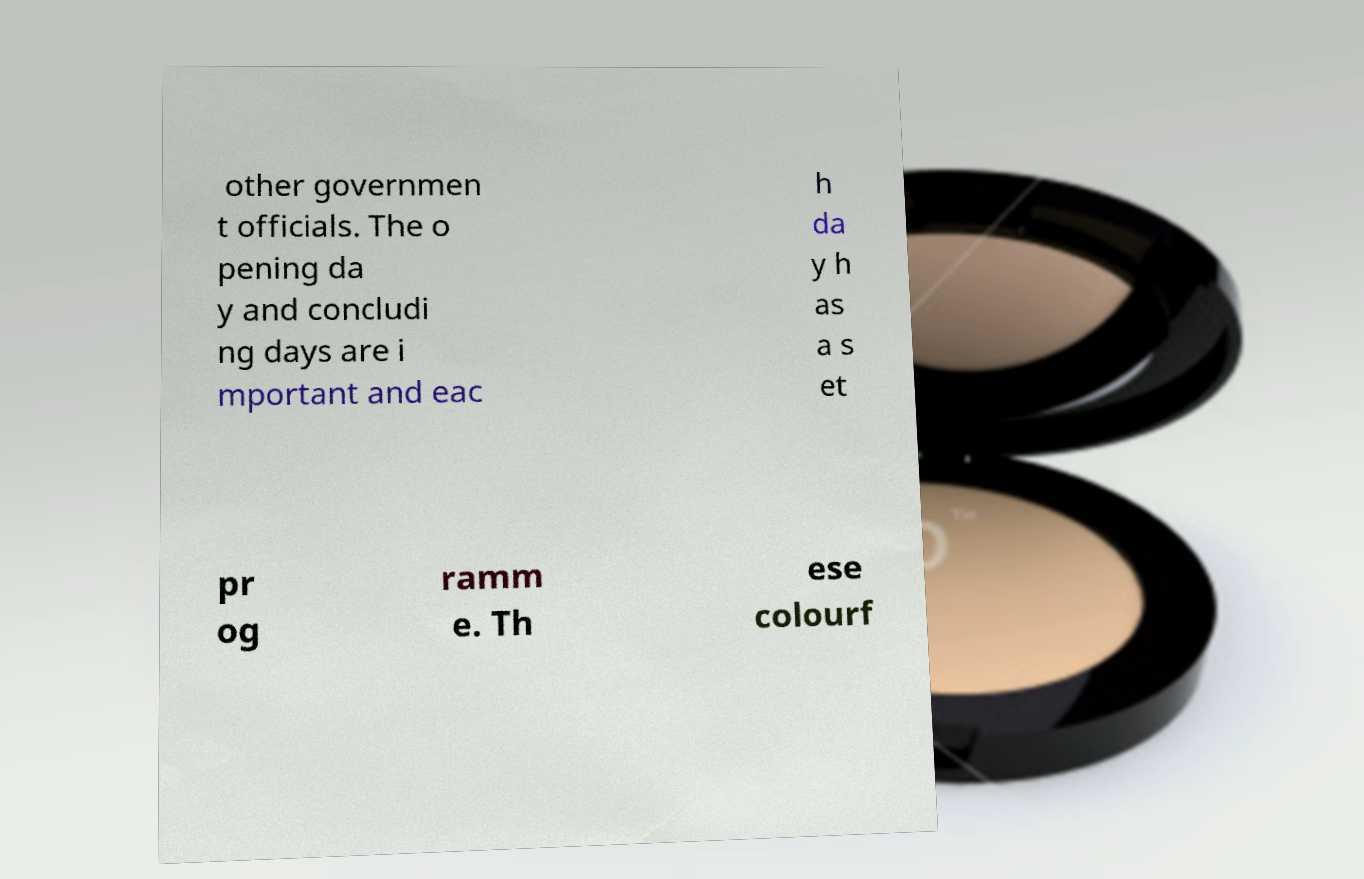Can you accurately transcribe the text from the provided image for me? other governmen t officials. The o pening da y and concludi ng days are i mportant and eac h da y h as a s et pr og ramm e. Th ese colourf 